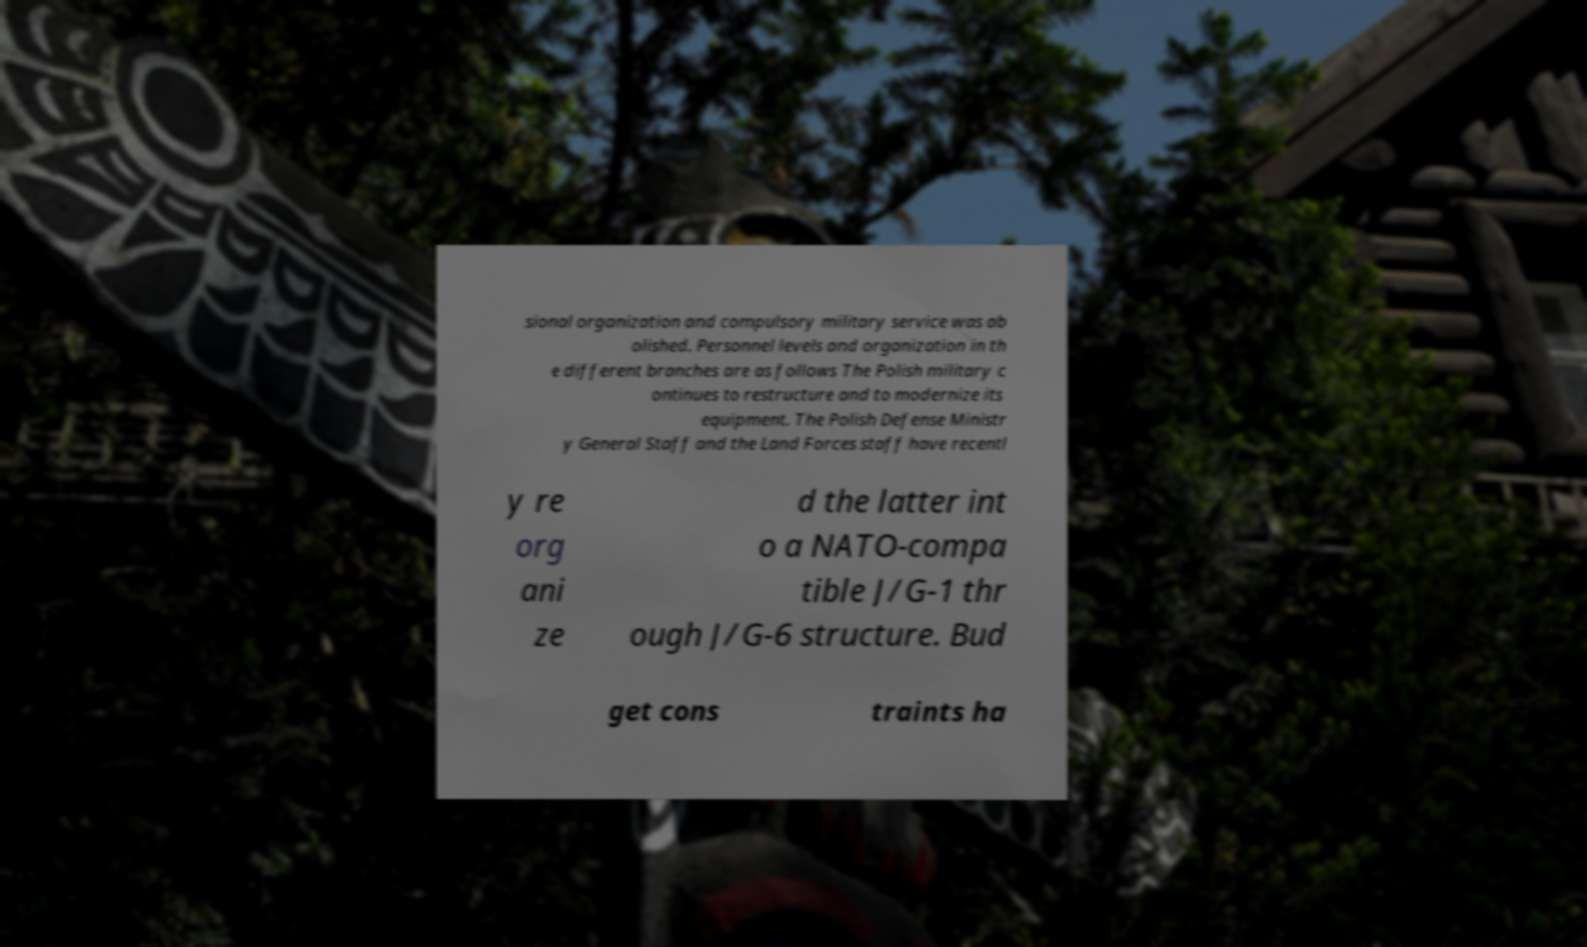Could you assist in decoding the text presented in this image and type it out clearly? sional organization and compulsory military service was ab olished. Personnel levels and organization in th e different branches are as follows The Polish military c ontinues to restructure and to modernize its equipment. The Polish Defense Ministr y General Staff and the Land Forces staff have recentl y re org ani ze d the latter int o a NATO-compa tible J/G-1 thr ough J/G-6 structure. Bud get cons traints ha 